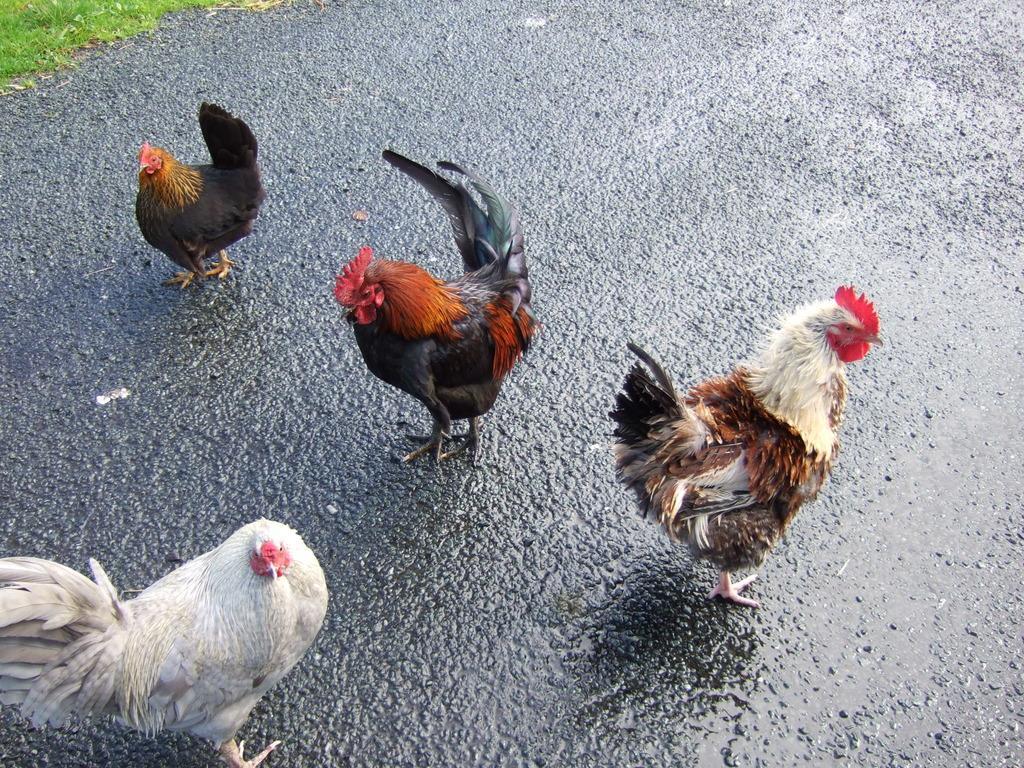Could you give a brief overview of what you see in this image? In this image, we can see roosters and hens on the road. 